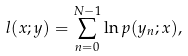<formula> <loc_0><loc_0><loc_500><loc_500>l ( x ; y ) = \sum _ { n = 0 } ^ { N - 1 } \ln p ( y _ { n } ; x ) ,</formula> 